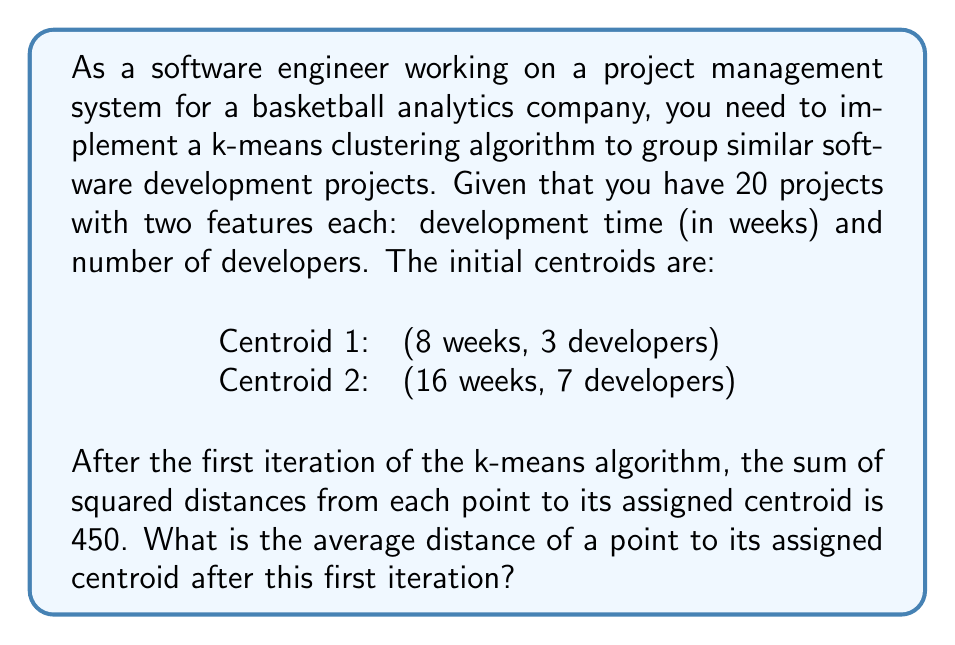Help me with this question. To solve this problem, we need to follow these steps:

1) Recall that k-means clustering aims to minimize the sum of squared distances between data points and their assigned centroids.

2) We're given that after the first iteration, the sum of squared distances is 450.

3) To find the average distance, we first need to find the average squared distance:

   Average squared distance = $\frac{\text{Sum of squared distances}}{\text{Number of data points}}$

   $$ \text{Average squared distance} = \frac{450}{20} = 22.5 $$

4) The average distance is the square root of the average squared distance:

   $$ \text{Average distance} = \sqrt{\text{Average squared distance}} = \sqrt{22.5} $$

5) Simplify $\sqrt{22.5}$:
   
   $\sqrt{22.5} = \sqrt{9 \times 2.5} = 3\sqrt{2.5} \approx 4.74$

Therefore, the average distance of a point to its assigned centroid after the first iteration is $3\sqrt{2.5}$ or approximately 4.74 units.
Answer: $3\sqrt{2.5}$ units (or approximately 4.74 units) 